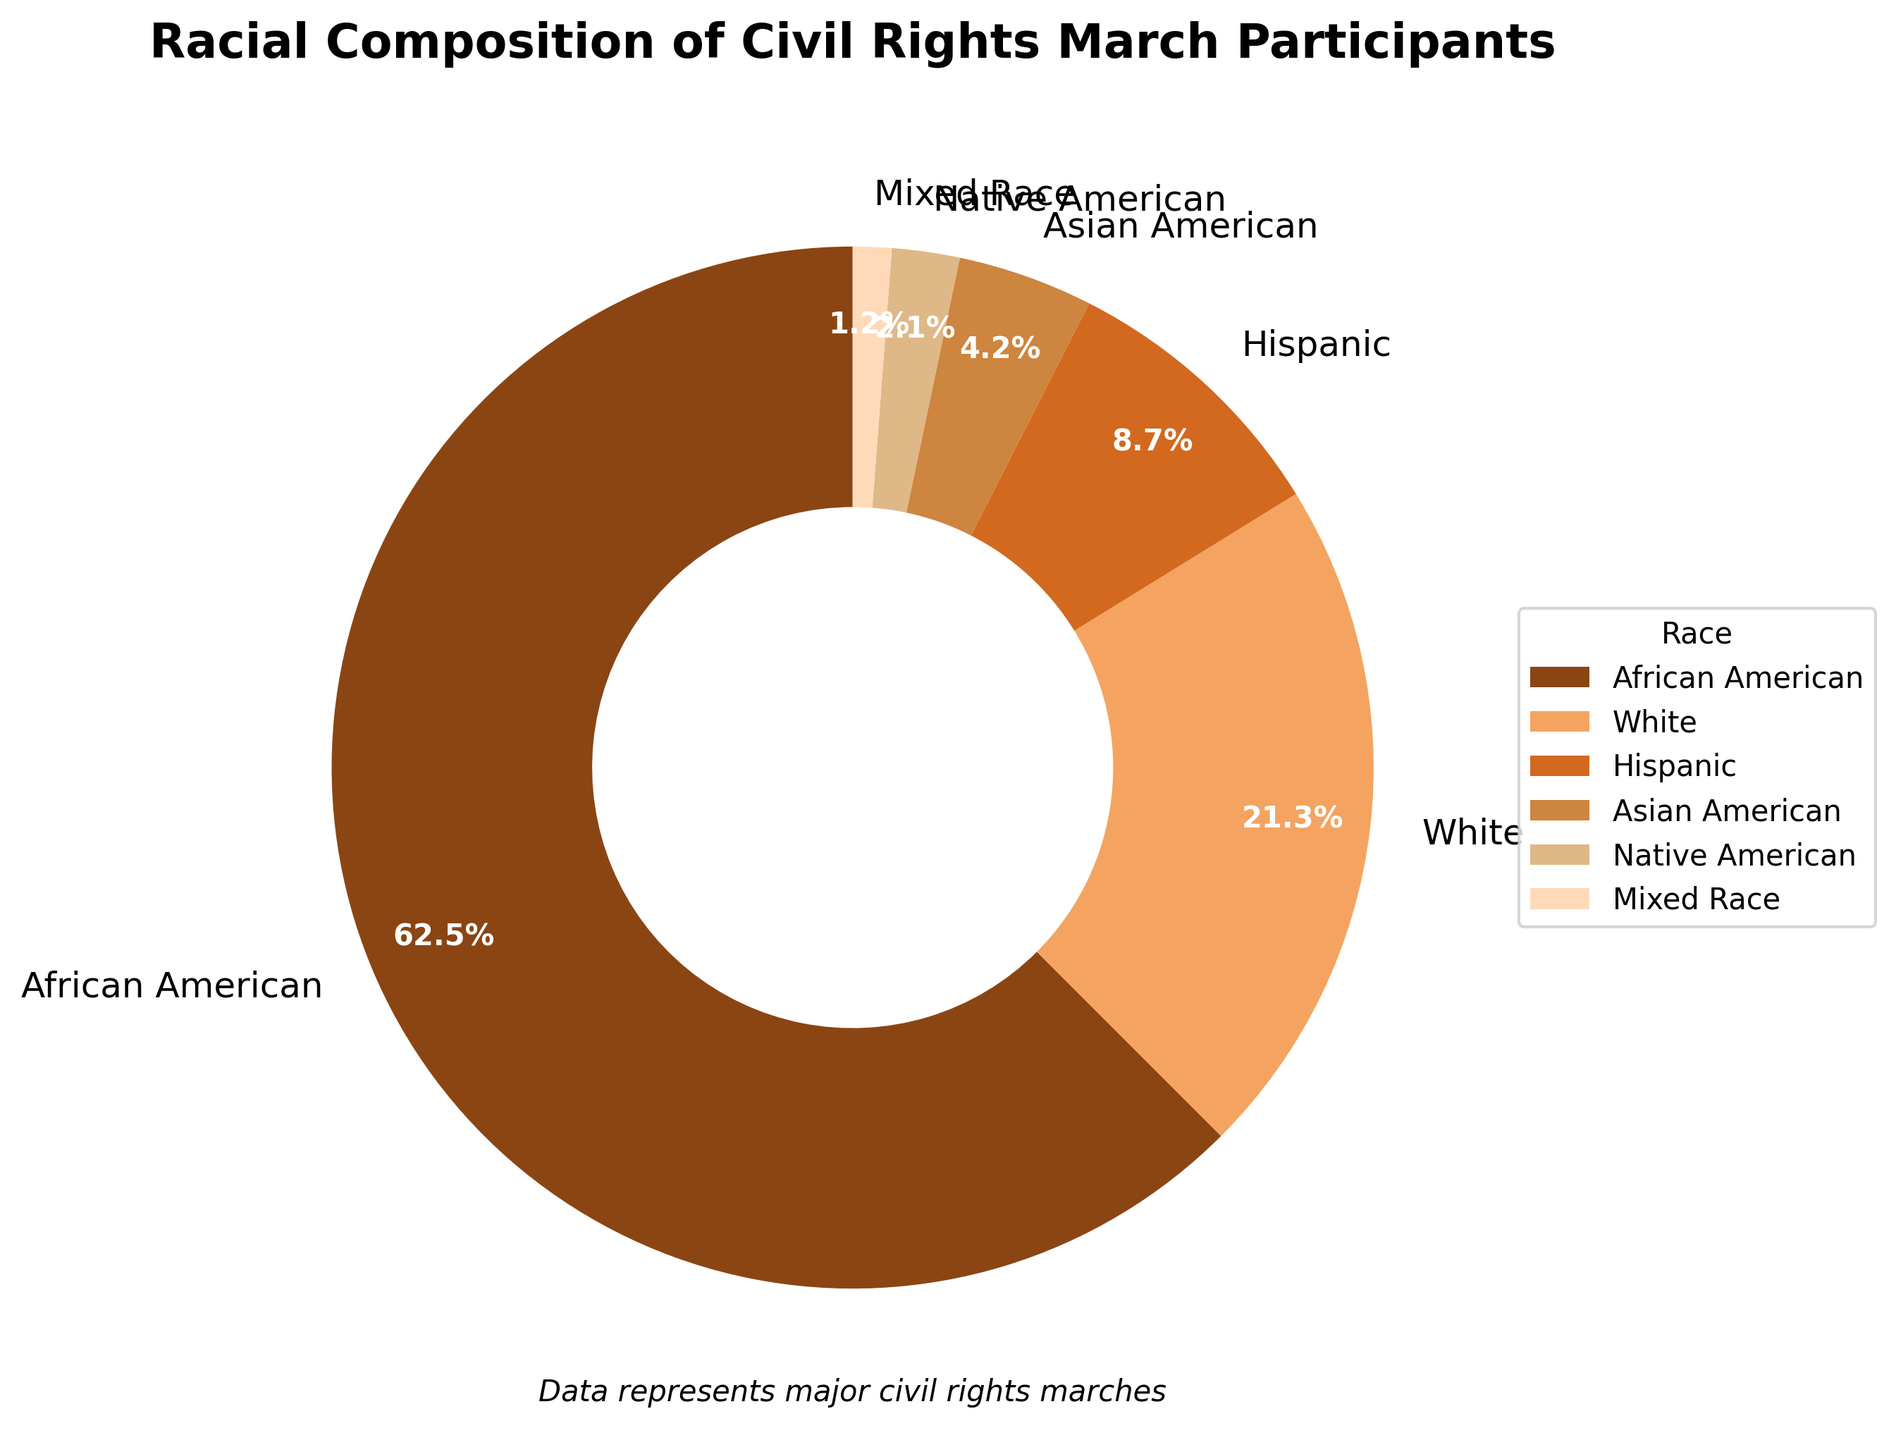What percentage of participants were either Hispanic or Asian American? Sum the percentages for Hispanic and Asian American: 8.7% + 4.2%. Therefore, the combined percentage is 8.7 + 4.2 = 12.9%.
Answer: 12.9% Which race had the highest representation in these civil rights marches? Refer to the pie chart; African American participants had the highest percentage at 62.5%.
Answer: African American How much greater was the percentage of White participants compared to Native American participants? Subtract the percentage of Native American participants from White participants: 21.3% - 2.1%. Therefore, the difference is 21.3 - 2.1 = 19.2%.
Answer: 19.2% How does the percentage of Mixed Race participants compare to Asian American participants? Compare the percentages directly; Mixed Race is 1.2% and Asian American is 4.2%. Asian American participants had a higher percentage than Mixed Race participants.
Answer: Asian American participants had a higher percentage If we combine the percentages of Mixed Race and Native American, is it still less than the percentage of Hispanic participants? Add the percentages of Mixed Race and Native American: 1.2% + 2.1%. This results in 3.3%, which is less than 8.7%, the percentage of Hispanic participants.
Answer: Yes, it is still less How does the visual appearance of the wedge for African Americans compare to that for Mixed Race participants in terms of size? Visually, the wedge representing African American participants is much larger than the wedge for Mixed Race participants, indicating a higher percentage (62.5% vs. 1.2%).
Answer: African American wedge is much larger What is the combined percentage of all participants who are neither African American nor White? Subtract the sum of the percentages for African American and White from 100%: 100% - (62.5% + 21.3%) = 100% - 83.8% = 16.2%.
Answer: 16.2% Do White participants represent more than a quarter of the total participants? Compare the percentage of White participants (21.3%) to 25%; 21.3% is less than 25%.
Answer: No Which two racial groups have the smallest representation in these civil rights marches? From the pie chart, Mixed Race (1.2%) and Native American (2.1%) have the smallest percentages.
Answer: Mixed Race and Native American 